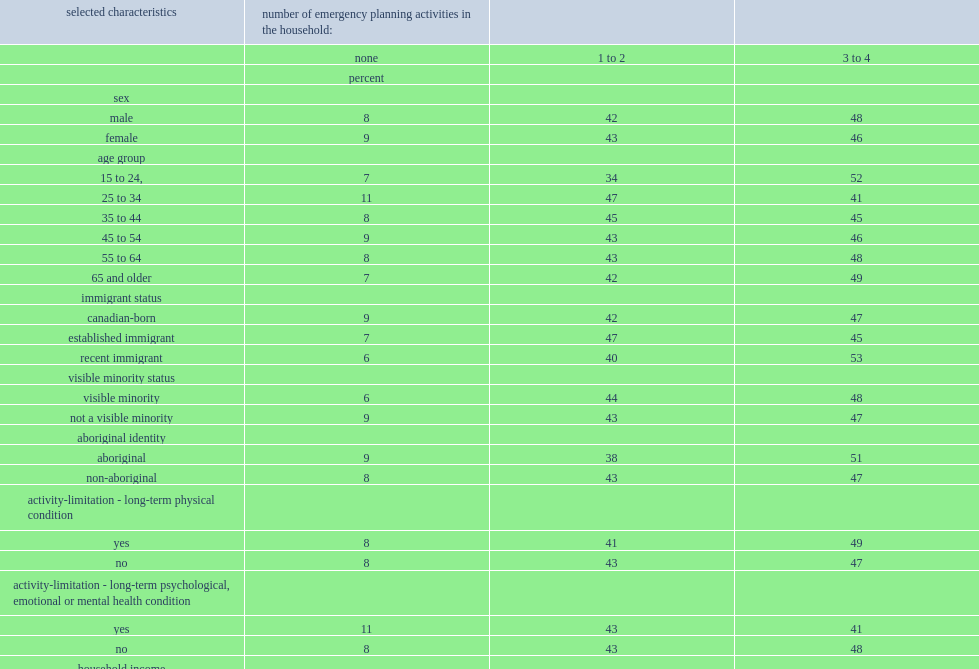It is also noteworthy that living in a household that participated in a moderately high or high number of emergency planning activities was most prevalent among the youngest age group, those aged 15 to 24 in 2014,what is the percentage of it? 52.0. 